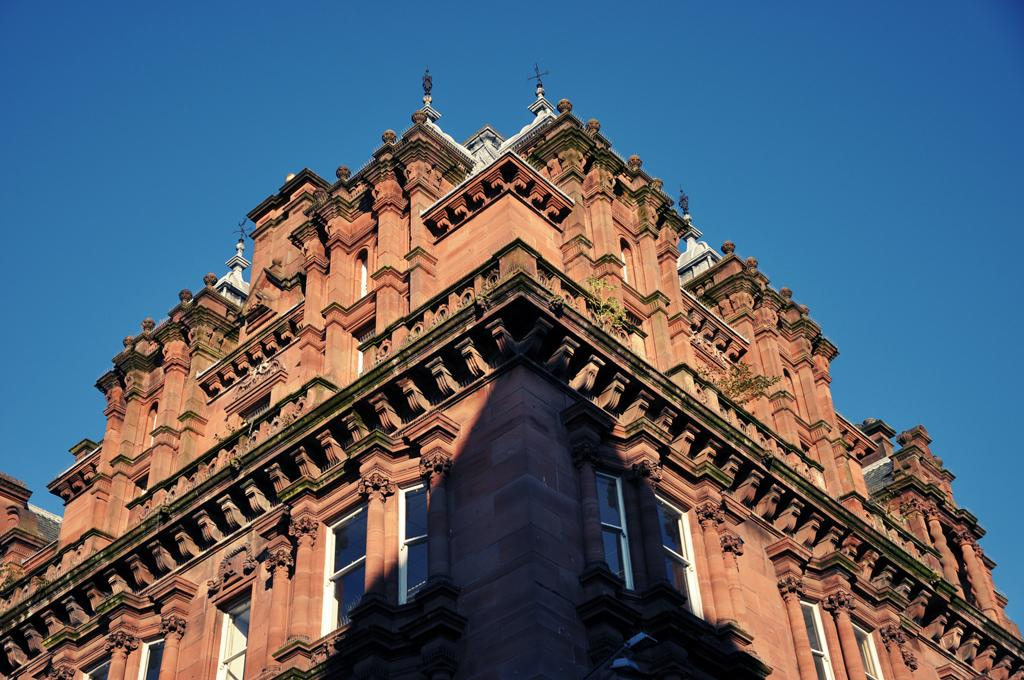What type of structure is present in the image? There is a building in the image. What feature of the building is mentioned in the facts? The building has windows. What can be seen in the background of the image? The sky is visible in the background of the image. What color is the sky in the image? The color of the sky is blue. How many basketballs can be seen on the roof of the building in the image? There are no basketballs present in the image, as it only features a building with windows and a blue sky in the background. 